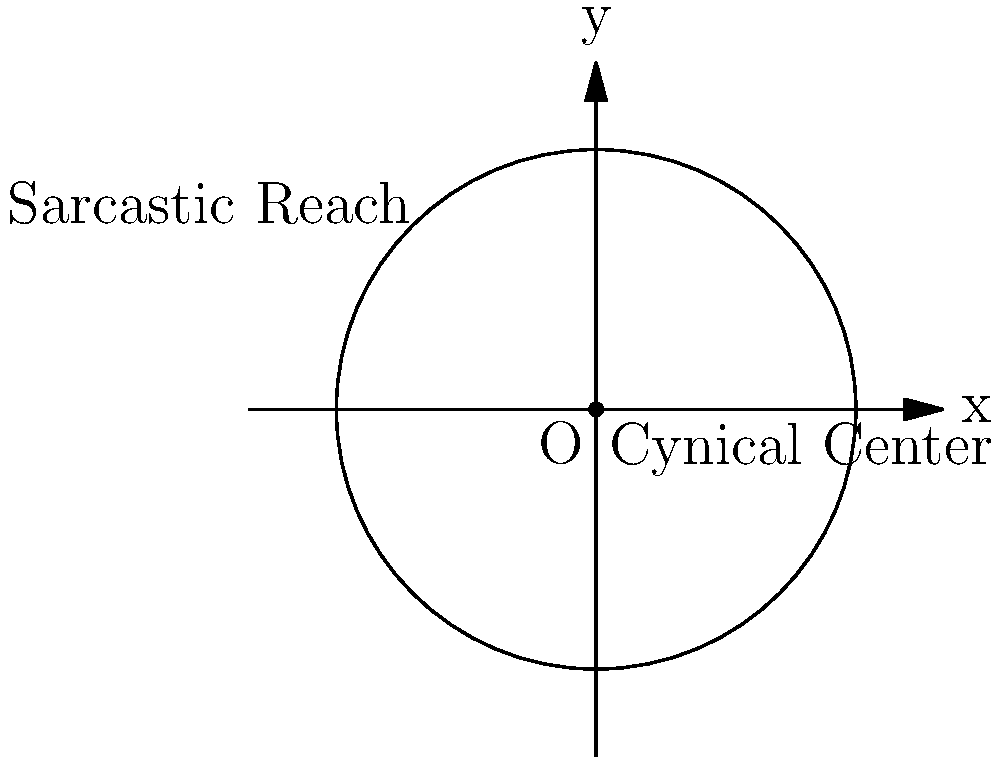In the Cartesian plane of poetic existence, a cynical poet's worldview is represented by a circle. The center of this circle, located at the origin (0, 0), symbolizes the poet's cynical core. The radius of the circle, measuring 3 units, represents the reach of the poet's sarcasm. If a historical event occurs at point P(2, -2), determine whether this event falls within the poet's sphere of cynical commentary. Express your answer in terms of the general equation of a circle, where $$(x-h)^2 + (y-k)^2 = r^2$$. To solve this problem, we'll follow these steps:

1) The general equation of a circle is $$(x-h)^2 + (y-k)^2 = r^2$$, where (h,k) is the center and r is the radius.

2) In this case, the center is at (0,0) and the radius is 3. So our equation becomes:
   $$x^2 + y^2 = 3^2 = 9$$

3) To determine if the point P(2, -2) is within the circle, we substitute its coordinates into the left side of the equation:
   $$(2)^2 + (-2)^2 = 4 + 4 = 8$$

4) Since 8 < 9, the point lies inside the circle.

5) Therefore, the historical event at P(2, -2) falls within the poet's sphere of cynical commentary.

6) To express this using the general equation, we say that the point satisfies:
   $$(x-0)^2 + (y-0)^2 < 3^2$$
   or simply: $$x^2 + y^2 < 9$$
Answer: $x^2 + y^2 < 9$ 